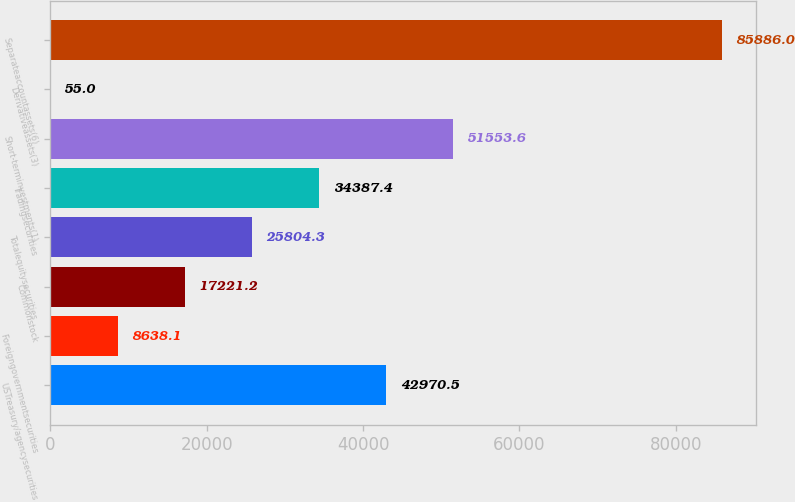<chart> <loc_0><loc_0><loc_500><loc_500><bar_chart><fcel>USTreasury/agencysecurities<fcel>Foreigngovernmentsecurities<fcel>Commonstock<fcel>Totalequitysecurities<fcel>Tradingsecurities<fcel>Short-terminvestments(1)<fcel>Derivativeassets(3)<fcel>Separateaccountassets(6)<nl><fcel>42970.5<fcel>8638.1<fcel>17221.2<fcel>25804.3<fcel>34387.4<fcel>51553.6<fcel>55<fcel>85886<nl></chart> 